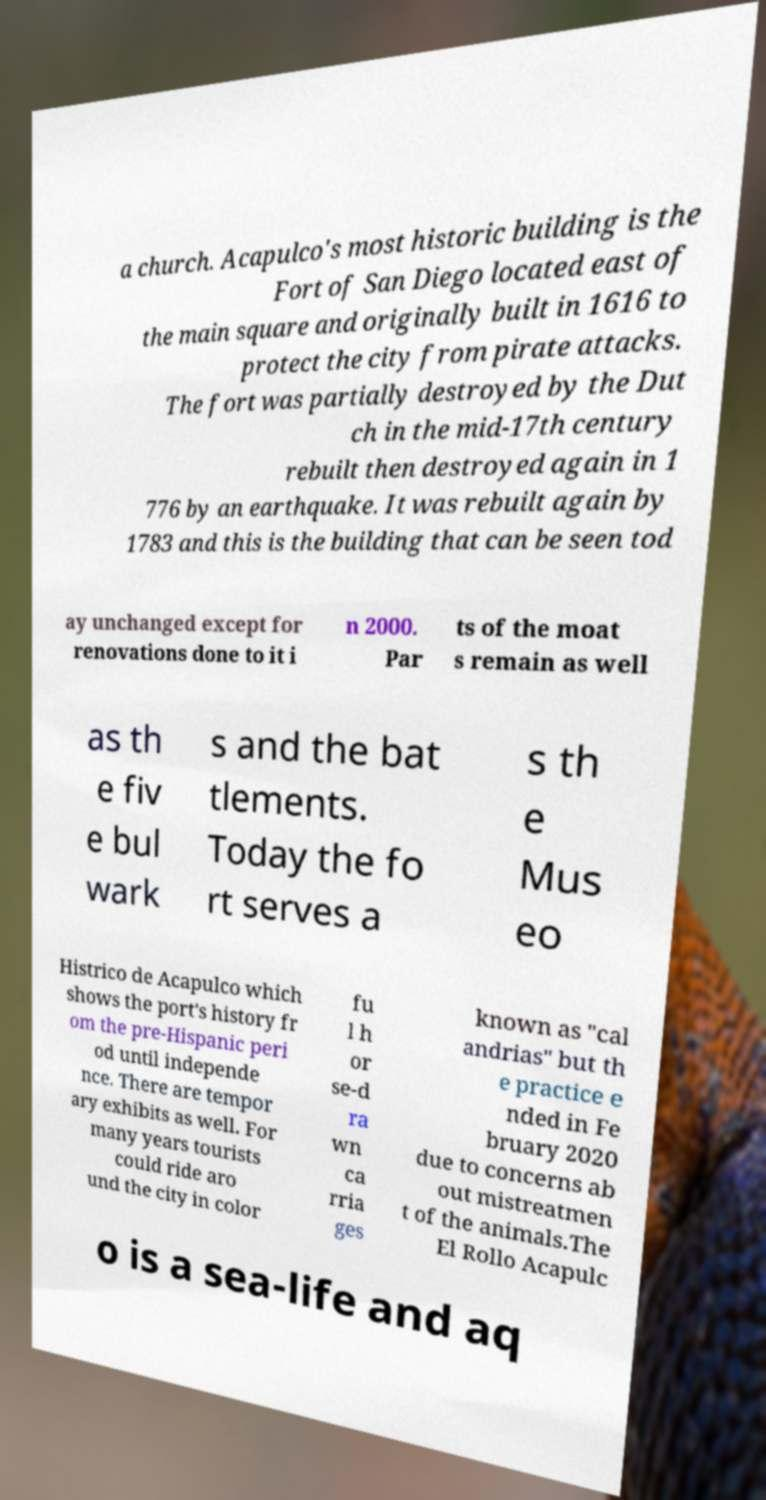Could you assist in decoding the text presented in this image and type it out clearly? a church. Acapulco's most historic building is the Fort of San Diego located east of the main square and originally built in 1616 to protect the city from pirate attacks. The fort was partially destroyed by the Dut ch in the mid-17th century rebuilt then destroyed again in 1 776 by an earthquake. It was rebuilt again by 1783 and this is the building that can be seen tod ay unchanged except for renovations done to it i n 2000. Par ts of the moat s remain as well as th e fiv e bul wark s and the bat tlements. Today the fo rt serves a s th e Mus eo Histrico de Acapulco which shows the port's history fr om the pre-Hispanic peri od until independe nce. There are tempor ary exhibits as well. For many years tourists could ride aro und the city in color fu l h or se-d ra wn ca rria ges known as "cal andrias" but th e practice e nded in Fe bruary 2020 due to concerns ab out mistreatmen t of the animals.The El Rollo Acapulc o is a sea-life and aq 